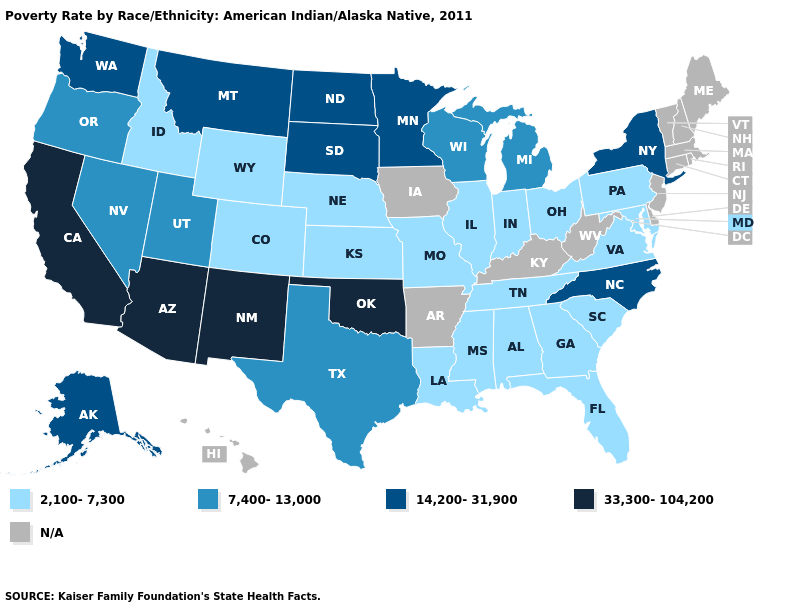What is the value of Arizona?
Keep it brief. 33,300-104,200. Among the states that border Virginia , does North Carolina have the lowest value?
Keep it brief. No. Does Virginia have the highest value in the USA?
Keep it brief. No. Name the states that have a value in the range 33,300-104,200?
Short answer required. Arizona, California, New Mexico, Oklahoma. Among the states that border Colorado , does Arizona have the highest value?
Write a very short answer. Yes. Which states have the highest value in the USA?
Give a very brief answer. Arizona, California, New Mexico, Oklahoma. What is the value of Indiana?
Short answer required. 2,100-7,300. What is the value of Oregon?
Write a very short answer. 7,400-13,000. Does North Dakota have the highest value in the USA?
Quick response, please. No. What is the value of North Carolina?
Be succinct. 14,200-31,900. Which states have the lowest value in the USA?
Give a very brief answer. Alabama, Colorado, Florida, Georgia, Idaho, Illinois, Indiana, Kansas, Louisiana, Maryland, Mississippi, Missouri, Nebraska, Ohio, Pennsylvania, South Carolina, Tennessee, Virginia, Wyoming. Is the legend a continuous bar?
Keep it brief. No. What is the value of South Dakota?
Short answer required. 14,200-31,900. Name the states that have a value in the range 14,200-31,900?
Write a very short answer. Alaska, Minnesota, Montana, New York, North Carolina, North Dakota, South Dakota, Washington. 